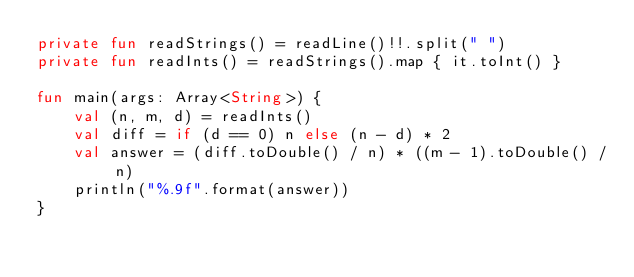<code> <loc_0><loc_0><loc_500><loc_500><_Kotlin_>private fun readStrings() = readLine()!!.split(" ")
private fun readInts() = readStrings().map { it.toInt() }

fun main(args: Array<String>) {
    val (n, m, d) = readInts()
    val diff = if (d == 0) n else (n - d) * 2
    val answer = (diff.toDouble() / n) * ((m - 1).toDouble() / n)
    println("%.9f".format(answer))
}</code> 